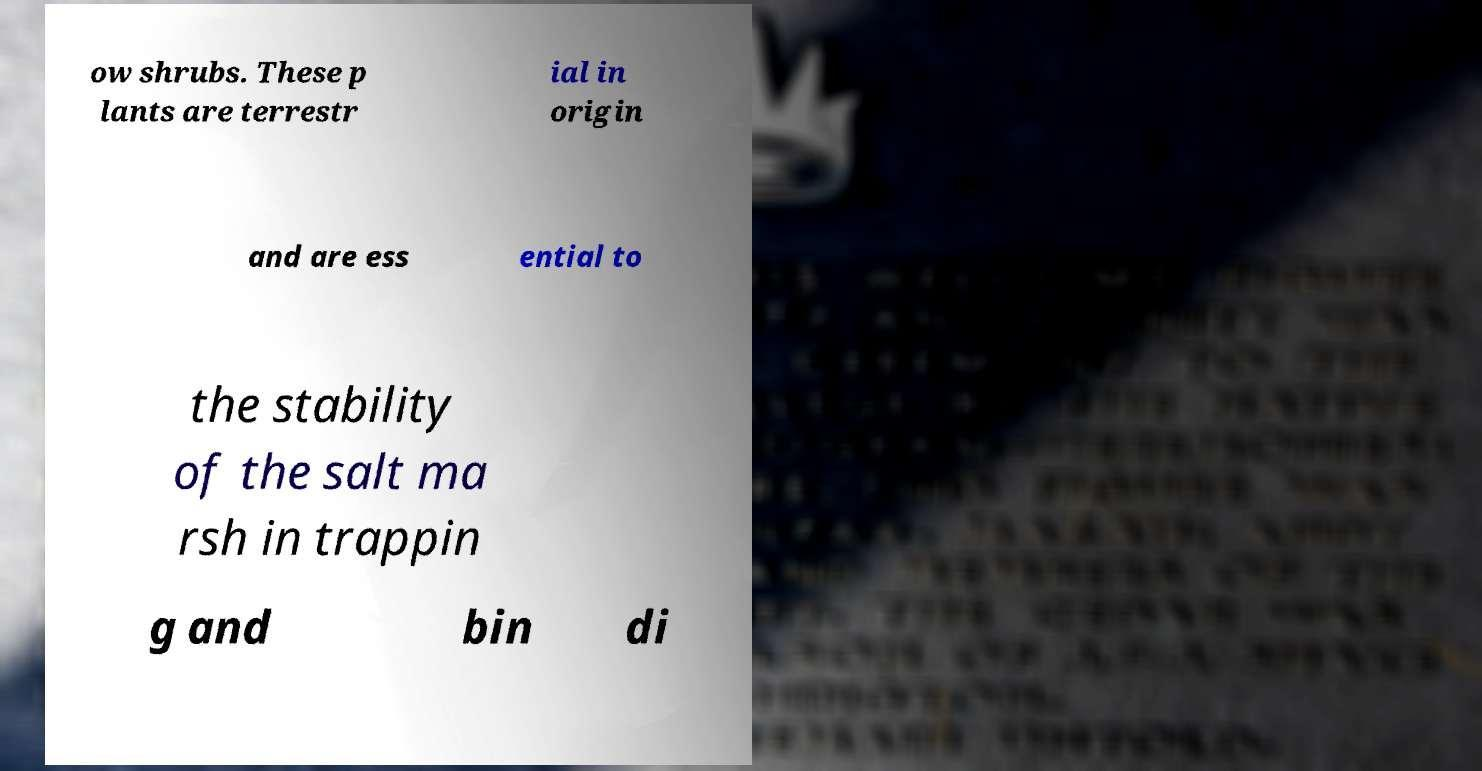Please identify and transcribe the text found in this image. ow shrubs. These p lants are terrestr ial in origin and are ess ential to the stability of the salt ma rsh in trappin g and bin di 